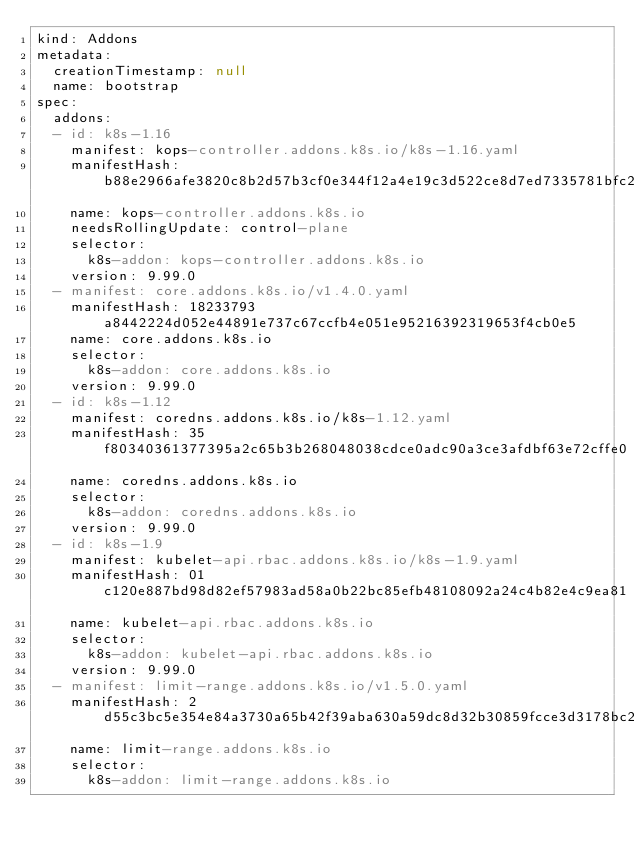<code> <loc_0><loc_0><loc_500><loc_500><_YAML_>kind: Addons
metadata:
  creationTimestamp: null
  name: bootstrap
spec:
  addons:
  - id: k8s-1.16
    manifest: kops-controller.addons.k8s.io/k8s-1.16.yaml
    manifestHash: b88e2966afe3820c8b2d57b3cf0e344f12a4e19c3d522ce8d7ed7335781bfc24
    name: kops-controller.addons.k8s.io
    needsRollingUpdate: control-plane
    selector:
      k8s-addon: kops-controller.addons.k8s.io
    version: 9.99.0
  - manifest: core.addons.k8s.io/v1.4.0.yaml
    manifestHash: 18233793a8442224d052e44891e737c67ccfb4e051e95216392319653f4cb0e5
    name: core.addons.k8s.io
    selector:
      k8s-addon: core.addons.k8s.io
    version: 9.99.0
  - id: k8s-1.12
    manifest: coredns.addons.k8s.io/k8s-1.12.yaml
    manifestHash: 35f80340361377395a2c65b3b268048038cdce0adc90a3ce3afdbf63e72cffe0
    name: coredns.addons.k8s.io
    selector:
      k8s-addon: coredns.addons.k8s.io
    version: 9.99.0
  - id: k8s-1.9
    manifest: kubelet-api.rbac.addons.k8s.io/k8s-1.9.yaml
    manifestHash: 01c120e887bd98d82ef57983ad58a0b22bc85efb48108092a24c4b82e4c9ea81
    name: kubelet-api.rbac.addons.k8s.io
    selector:
      k8s-addon: kubelet-api.rbac.addons.k8s.io
    version: 9.99.0
  - manifest: limit-range.addons.k8s.io/v1.5.0.yaml
    manifestHash: 2d55c3bc5e354e84a3730a65b42f39aba630a59dc8d32b30859fcce3d3178bc2
    name: limit-range.addons.k8s.io
    selector:
      k8s-addon: limit-range.addons.k8s.io</code> 